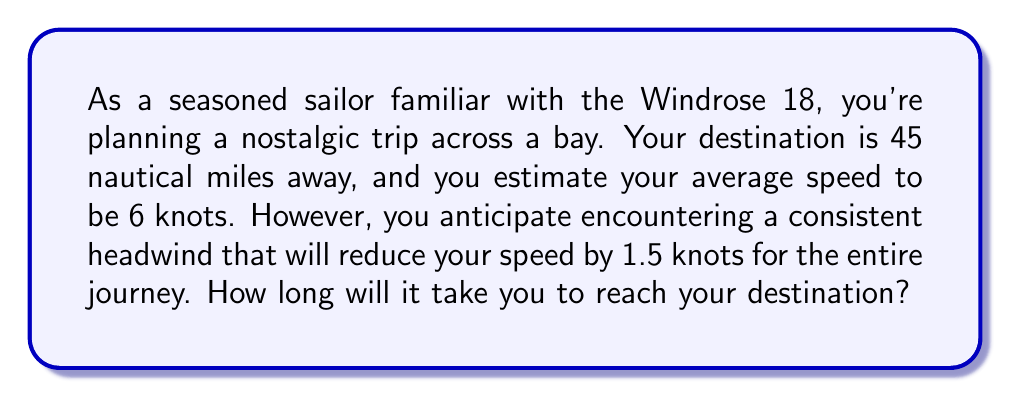Provide a solution to this math problem. To solve this problem, we'll use the fundamental relationship between distance, speed, and time:

$$\text{Distance} = \text{Speed} \times \text{Time}$$

We can rearrange this to find time:

$$\text{Time} = \frac{\text{Distance}}{\text{Speed}}$$

Given:
- Distance to destination: 45 nautical miles
- Estimated average speed: 6 knots
- Speed reduction due to headwind: 1.5 knots

First, we need to calculate the actual speed:
$$\text{Actual Speed} = 6 \text{ knots} - 1.5 \text{ knots} = 4.5 \text{ knots}$$

Now, we can plug our values into the time equation:

$$\text{Time} = \frac{45 \text{ nautical miles}}{4.5 \text{ knots}}$$

Simplifying:

$$\text{Time} = 10 \text{ hours}$$

Therefore, it will take 10 hours to reach the destination.
Answer: 10 hours 